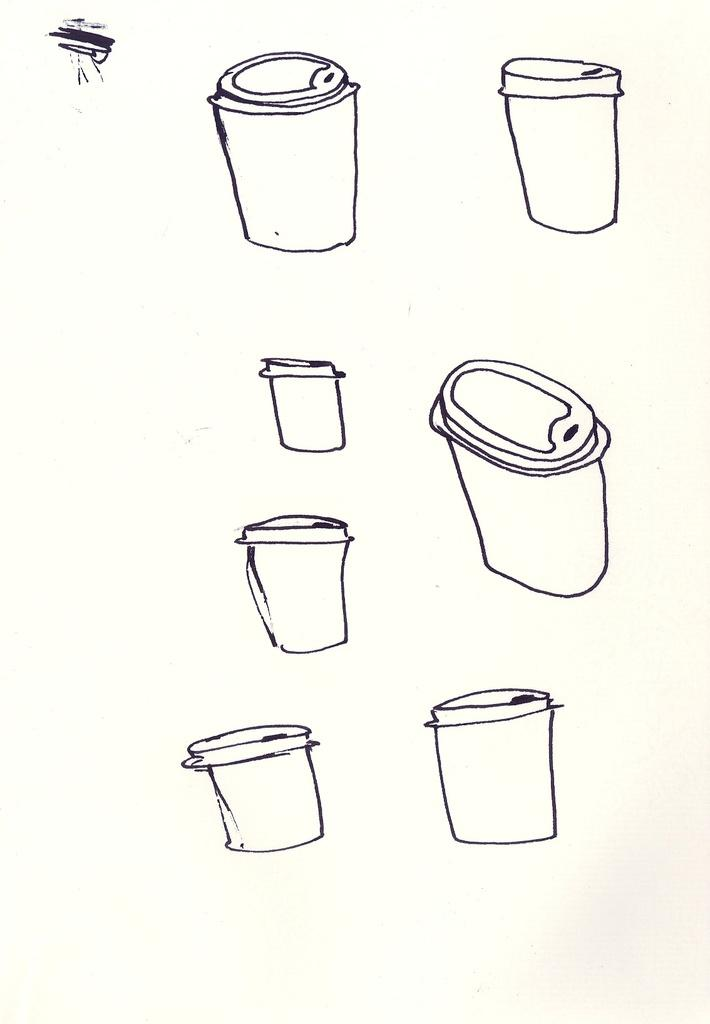What is the main subject of the image? There is an art piece in the image. What is depicted within the art piece? The art piece contains containers. How are the containers represented in the art piece? The containers are depicted on a canvas. How many geese are visible on the side of the art piece? There are no geese present in the image, and the art piece does not have a side as it is a two-dimensional representation on a canvas. 